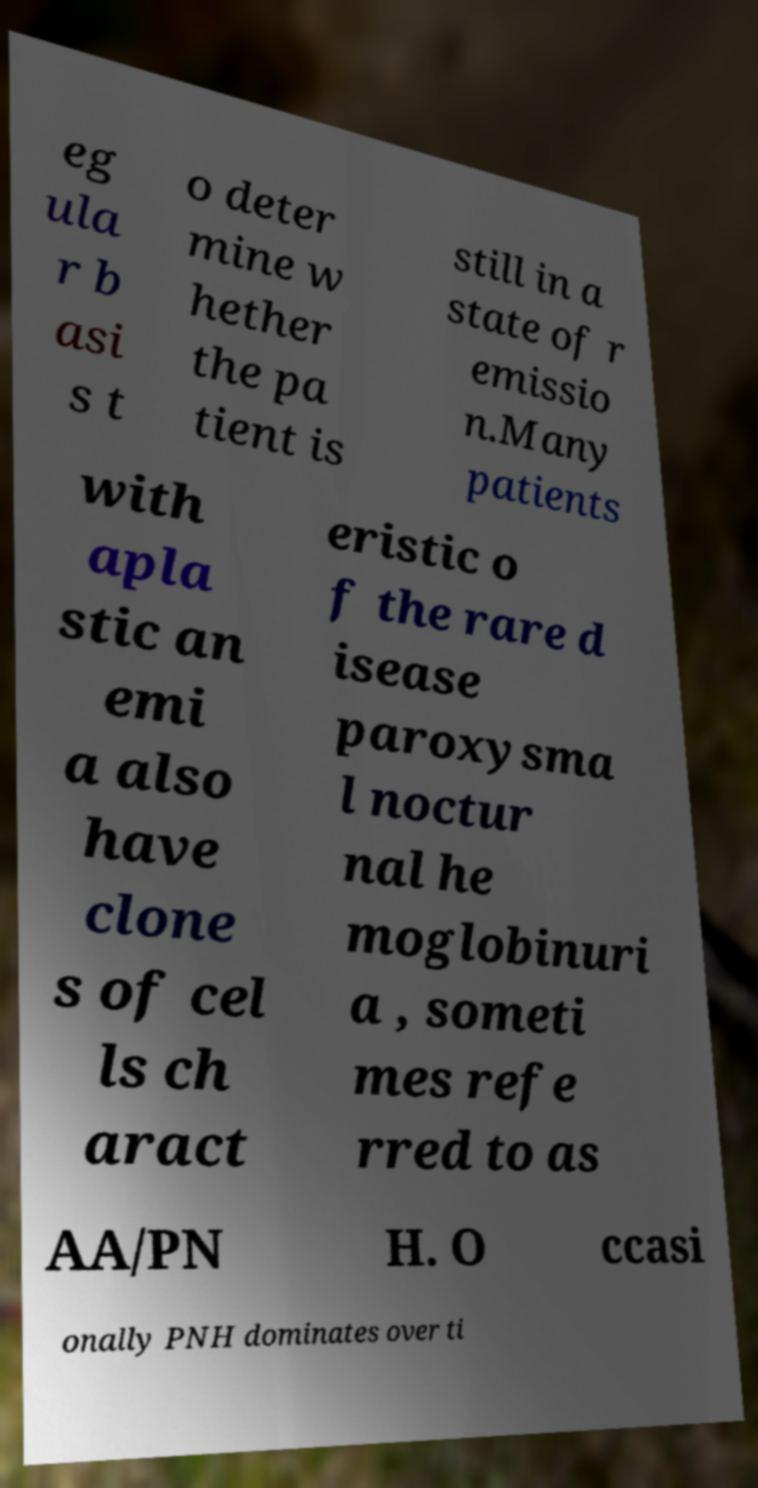There's text embedded in this image that I need extracted. Can you transcribe it verbatim? eg ula r b asi s t o deter mine w hether the pa tient is still in a state of r emissio n.Many patients with apla stic an emi a also have clone s of cel ls ch aract eristic o f the rare d isease paroxysma l noctur nal he moglobinuri a , someti mes refe rred to as AA/PN H. O ccasi onally PNH dominates over ti 